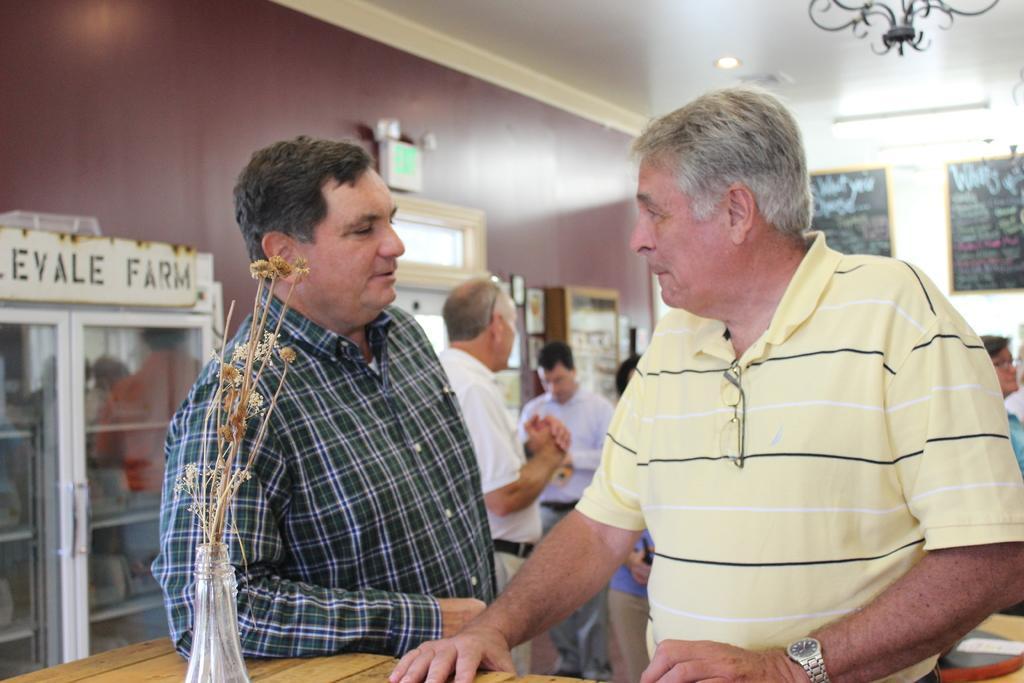Please provide a concise description of this image. There are two men standing in the foreground area of the image, there is an object on the table, there are people, posters, light, showcases and other objects in the background. 